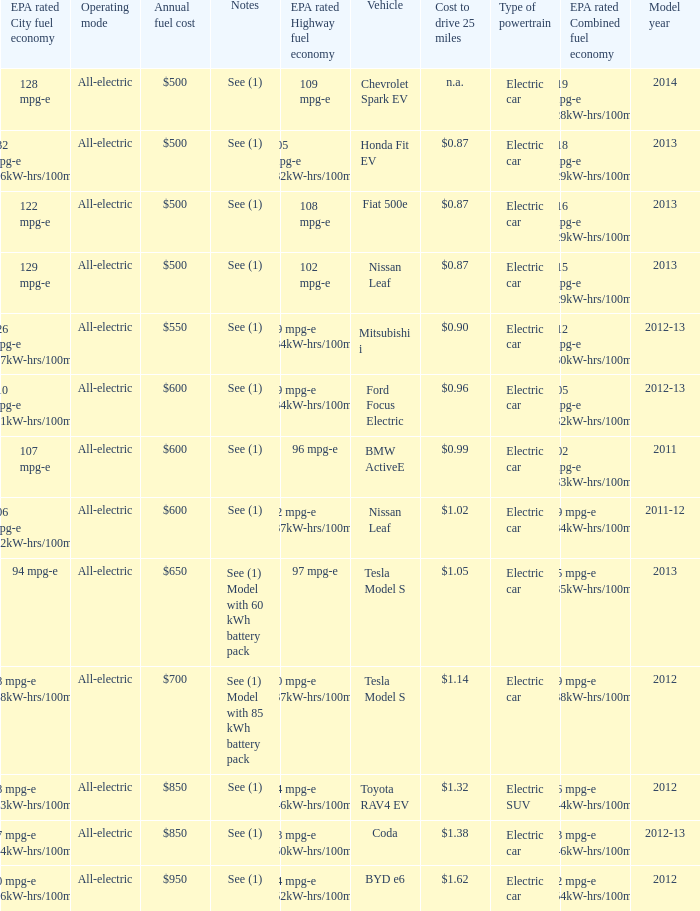What vehicle has an epa highway fuel economy of 109 mpg-e? Chevrolet Spark EV. Can you parse all the data within this table? {'header': ['EPA rated City fuel economy', 'Operating mode', 'Annual fuel cost', 'Notes', 'EPA rated Highway fuel economy', 'Vehicle', 'Cost to drive 25 miles', 'Type of powertrain', 'EPA rated Combined fuel economy', 'Model year'], 'rows': [['128 mpg-e', 'All-electric', '$500', 'See (1)', '109 mpg-e', 'Chevrolet Spark EV', 'n.a.', 'Electric car', '119 mpg-e (28kW-hrs/100mi)', '2014'], ['132 mpg-e (26kW-hrs/100mi)', 'All-electric', '$500', 'See (1)', '105 mpg-e (32kW-hrs/100mi)', 'Honda Fit EV', '$0.87', 'Electric car', '118 mpg-e (29kW-hrs/100mi)', '2013'], ['122 mpg-e', 'All-electric', '$500', 'See (1)', '108 mpg-e', 'Fiat 500e', '$0.87', 'Electric car', '116 mpg-e (29kW-hrs/100mi)', '2013'], ['129 mpg-e', 'All-electric', '$500', 'See (1)', '102 mpg-e', 'Nissan Leaf', '$0.87', 'Electric car', '115 mpg-e (29kW-hrs/100mi)', '2013'], ['126 mpg-e (27kW-hrs/100mi)', 'All-electric', '$550', 'See (1)', '99 mpg-e (34kW-hrs/100mi)', 'Mitsubishi i', '$0.90', 'Electric car', '112 mpg-e (30kW-hrs/100mi)', '2012-13'], ['110 mpg-e (31kW-hrs/100mi)', 'All-electric', '$600', 'See (1)', '99 mpg-e (34kW-hrs/100mi)', 'Ford Focus Electric', '$0.96', 'Electric car', '105 mpg-e (32kW-hrs/100mi)', '2012-13'], ['107 mpg-e', 'All-electric', '$600', 'See (1)', '96 mpg-e', 'BMW ActiveE', '$0.99', 'Electric car', '102 mpg-e (33kW-hrs/100mi)', '2011'], ['106 mpg-e (32kW-hrs/100mi)', 'All-electric', '$600', 'See (1)', '92 mpg-e (37kW-hrs/100mi)', 'Nissan Leaf', '$1.02', 'Electric car', '99 mpg-e (34kW-hrs/100mi)', '2011-12'], ['94 mpg-e', 'All-electric', '$650', 'See (1) Model with 60 kWh battery pack', '97 mpg-e', 'Tesla Model S', '$1.05', 'Electric car', '95 mpg-e (35kW-hrs/100mi)', '2013'], ['88 mpg-e (38kW-hrs/100mi)', 'All-electric', '$700', 'See (1) Model with 85 kWh battery pack', '90 mpg-e (37kW-hrs/100mi)', 'Tesla Model S', '$1.14', 'Electric car', '89 mpg-e (38kW-hrs/100mi)', '2012'], ['78 mpg-e (43kW-hrs/100mi)', 'All-electric', '$850', 'See (1)', '74 mpg-e (46kW-hrs/100mi)', 'Toyota RAV4 EV', '$1.32', 'Electric SUV', '76 mpg-e (44kW-hrs/100mi)', '2012'], ['77 mpg-e (44kW-hrs/100mi)', 'All-electric', '$850', 'See (1)', '68 mpg-e (50kW-hrs/100mi)', 'Coda', '$1.38', 'Electric car', '73 mpg-e (46kW-hrs/100mi)', '2012-13'], ['60 mpg-e (56kW-hrs/100mi)', 'All-electric', '$950', 'See (1)', '64 mpg-e (52kW-hrs/100mi)', 'BYD e6', '$1.62', 'Electric car', '62 mpg-e (54kW-hrs/100mi)', '2012']]} 